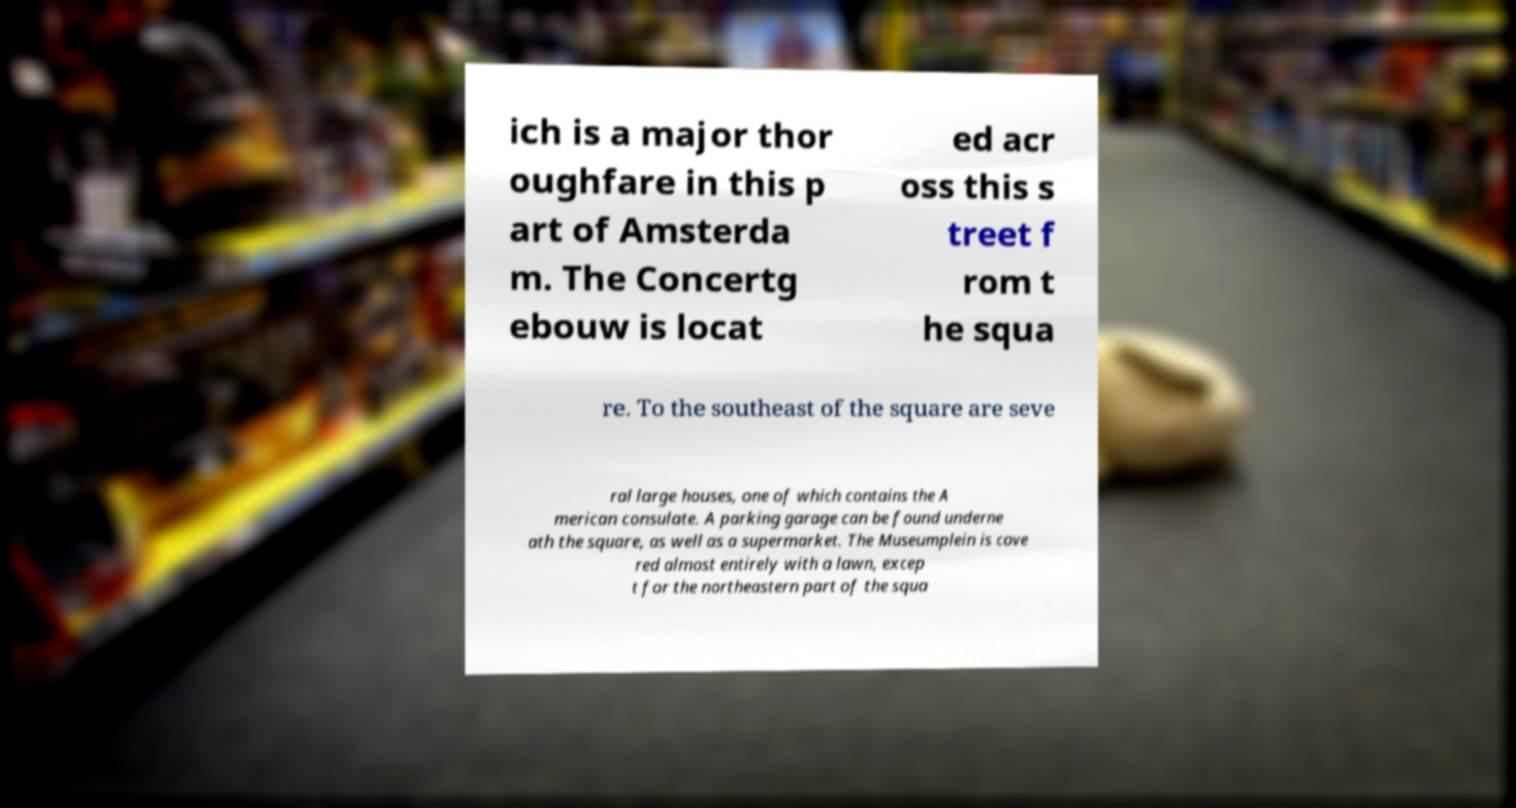For documentation purposes, I need the text within this image transcribed. Could you provide that? ich is a major thor oughfare in this p art of Amsterda m. The Concertg ebouw is locat ed acr oss this s treet f rom t he squa re. To the southeast of the square are seve ral large houses, one of which contains the A merican consulate. A parking garage can be found underne ath the square, as well as a supermarket. The Museumplein is cove red almost entirely with a lawn, excep t for the northeastern part of the squa 